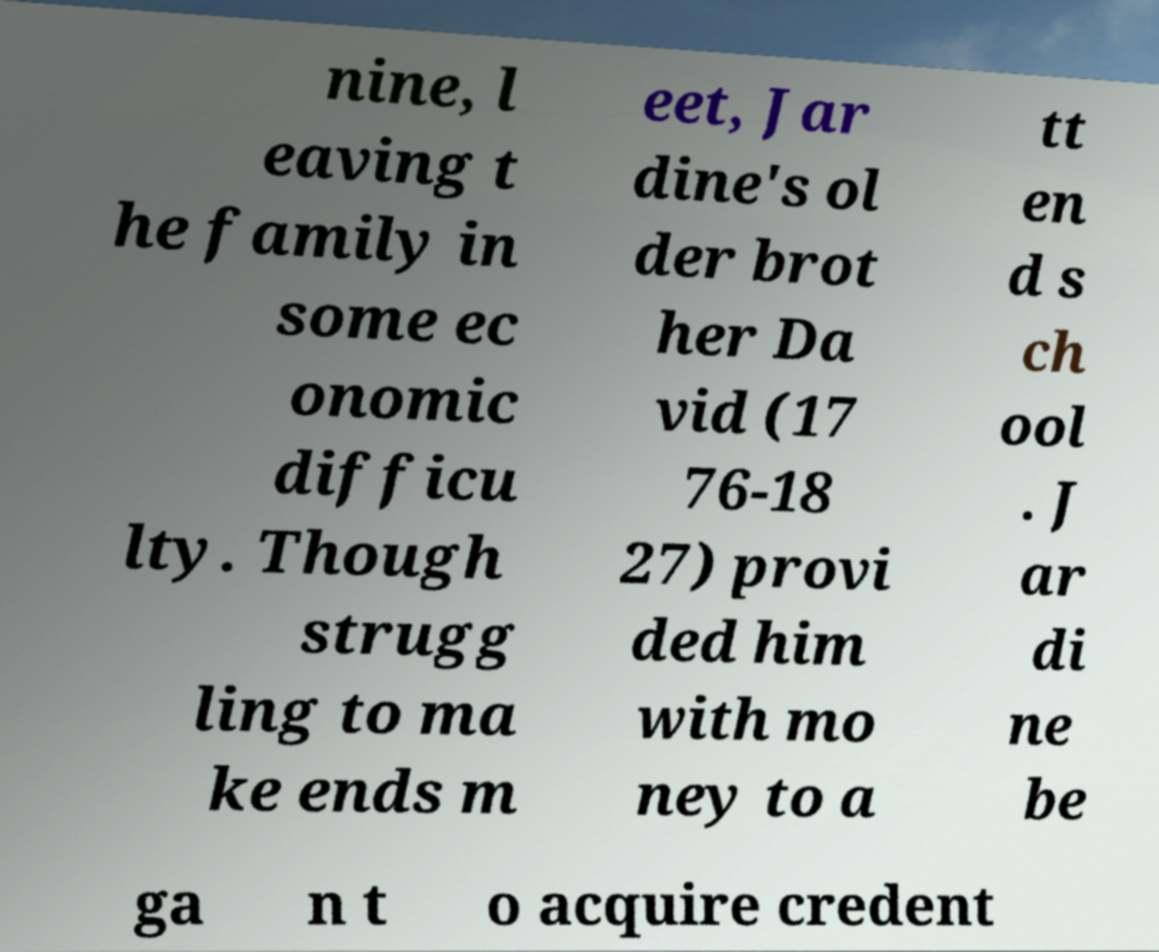There's text embedded in this image that I need extracted. Can you transcribe it verbatim? nine, l eaving t he family in some ec onomic difficu lty. Though strugg ling to ma ke ends m eet, Jar dine's ol der brot her Da vid (17 76-18 27) provi ded him with mo ney to a tt en d s ch ool . J ar di ne be ga n t o acquire credent 